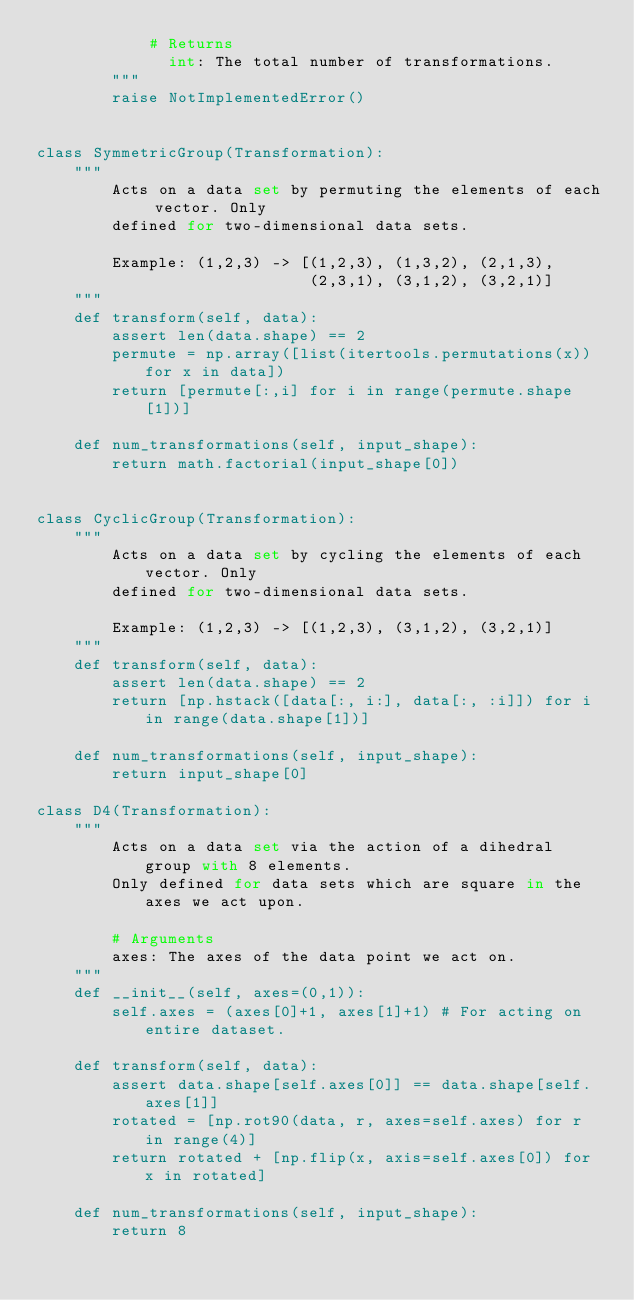<code> <loc_0><loc_0><loc_500><loc_500><_Python_>            # Returns
              int: The total number of transformations.
        """
        raise NotImplementedError()


class SymmetricGroup(Transformation):
    """
        Acts on a data set by permuting the elements of each vector. Only
        defined for two-dimensional data sets.
        
        Example: (1,2,3) -> [(1,2,3), (1,3,2), (2,1,3), 
                             (2,3,1), (3,1,2), (3,2,1)]
    """
    def transform(self, data):
        assert len(data.shape) == 2
        permute = np.array([list(itertools.permutations(x)) for x in data])
        return [permute[:,i] for i in range(permute.shape[1])]
    
    def num_transformations(self, input_shape):
        return math.factorial(input_shape[0])
    
    
class CyclicGroup(Transformation):
    """
        Acts on a data set by cycling the elements of each vector. Only
        defined for two-dimensional data sets.
        
        Example: (1,2,3) -> [(1,2,3), (3,1,2), (3,2,1)]
    """
    def transform(self, data):
        assert len(data.shape) == 2
        return [np.hstack([data[:, i:], data[:, :i]]) for i in range(data.shape[1])]
    
    def num_transformations(self, input_shape):
        return input_shape[0]
    
class D4(Transformation):
    """
        Acts on a data set via the action of a dihedral group with 8 elements.
        Only defined for data sets which are square in the axes we act upon.
        
        # Arguments
        axes: The axes of the data point we act on.
    """
    def __init__(self, axes=(0,1)):
        self.axes = (axes[0]+1, axes[1]+1) # For acting on entire dataset.
    
    def transform(self, data):
        assert data.shape[self.axes[0]] == data.shape[self.axes[1]]
        rotated = [np.rot90(data, r, axes=self.axes) for r in range(4)]
        return rotated + [np.flip(x, axis=self.axes[0]) for x in rotated]
    
    def num_transformations(self, input_shape):
        return 8</code> 